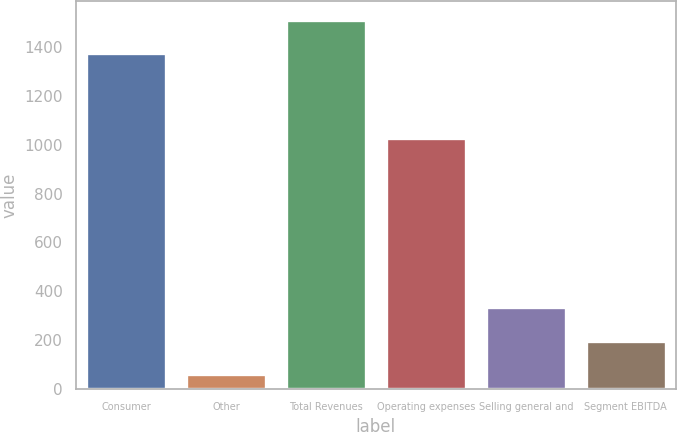Convert chart to OTSL. <chart><loc_0><loc_0><loc_500><loc_500><bar_chart><fcel>Consumer<fcel>Other<fcel>Total Revenues<fcel>Operating expenses<fcel>Selling general and<fcel>Segment EBITDA<nl><fcel>1374<fcel>60<fcel>1511.4<fcel>1029<fcel>334.8<fcel>197.4<nl></chart> 